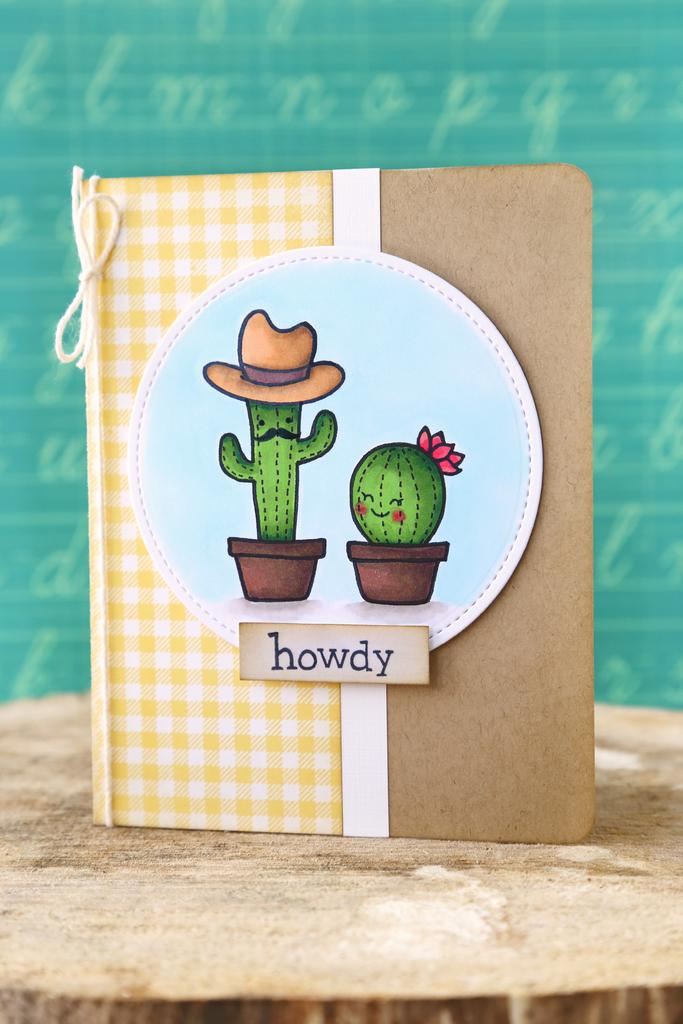What is the main object in the image? There is a book in the image. Where is the book placed? The book is on a wooden log block. What type of content does the book have? The book contains images of pots. Can you see any hills in the image? There are no hills visible in the image; it only features a book on a wooden log block with images of pots. 